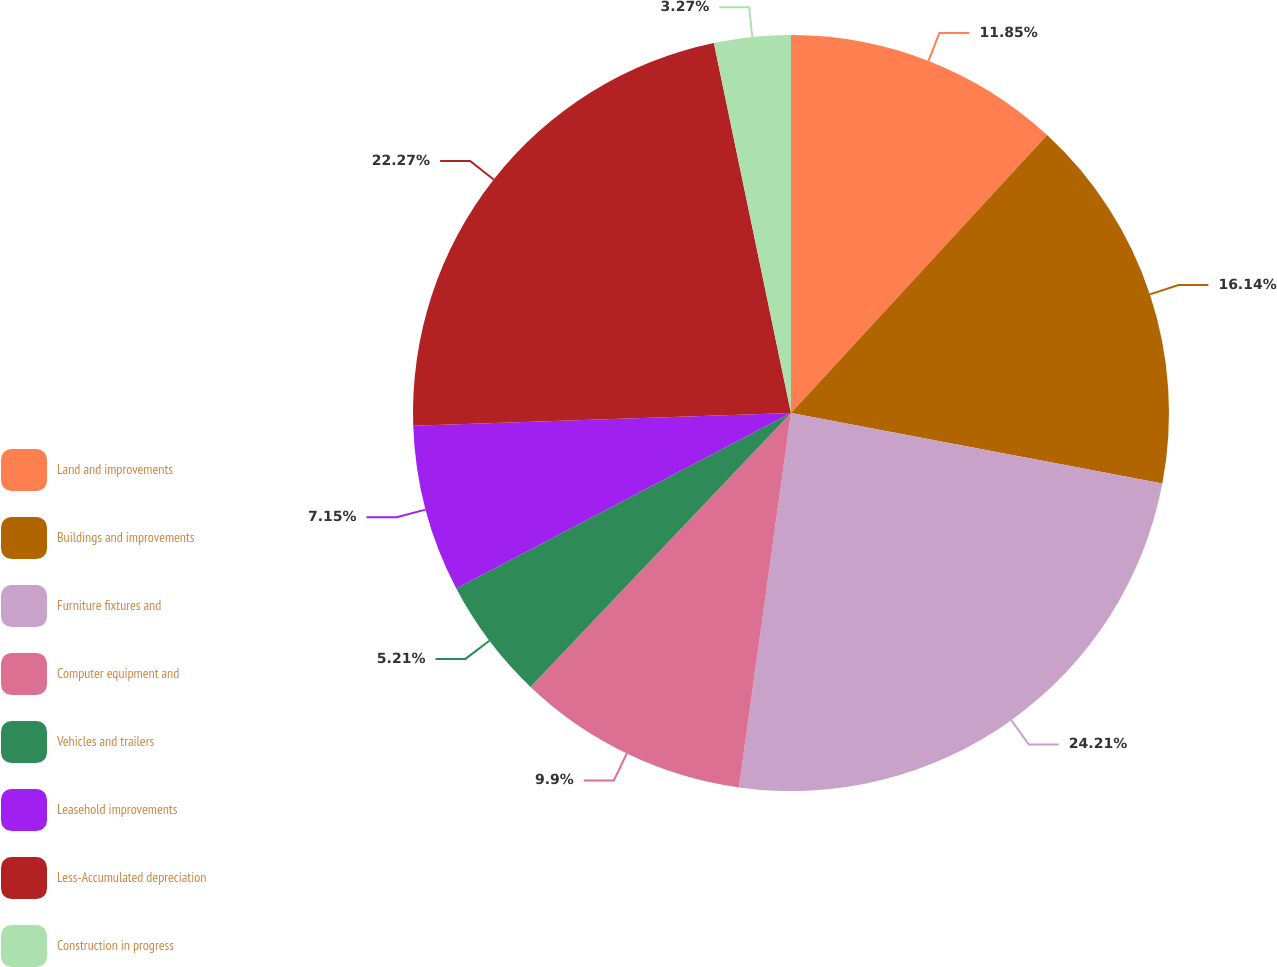Convert chart. <chart><loc_0><loc_0><loc_500><loc_500><pie_chart><fcel>Land and improvements<fcel>Buildings and improvements<fcel>Furniture fixtures and<fcel>Computer equipment and<fcel>Vehicles and trailers<fcel>Leasehold improvements<fcel>Less-Accumulated depreciation<fcel>Construction in progress<nl><fcel>11.85%<fcel>16.14%<fcel>24.21%<fcel>9.9%<fcel>5.21%<fcel>7.15%<fcel>22.27%<fcel>3.27%<nl></chart> 